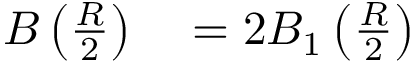Convert formula to latex. <formula><loc_0><loc_0><loc_500><loc_500>\begin{array} { r l } { B \left ( { \frac { R } { 2 } } \right ) } & = 2 B _ { 1 } \left ( { \frac { R } { 2 } } \right ) } \end{array}</formula> 